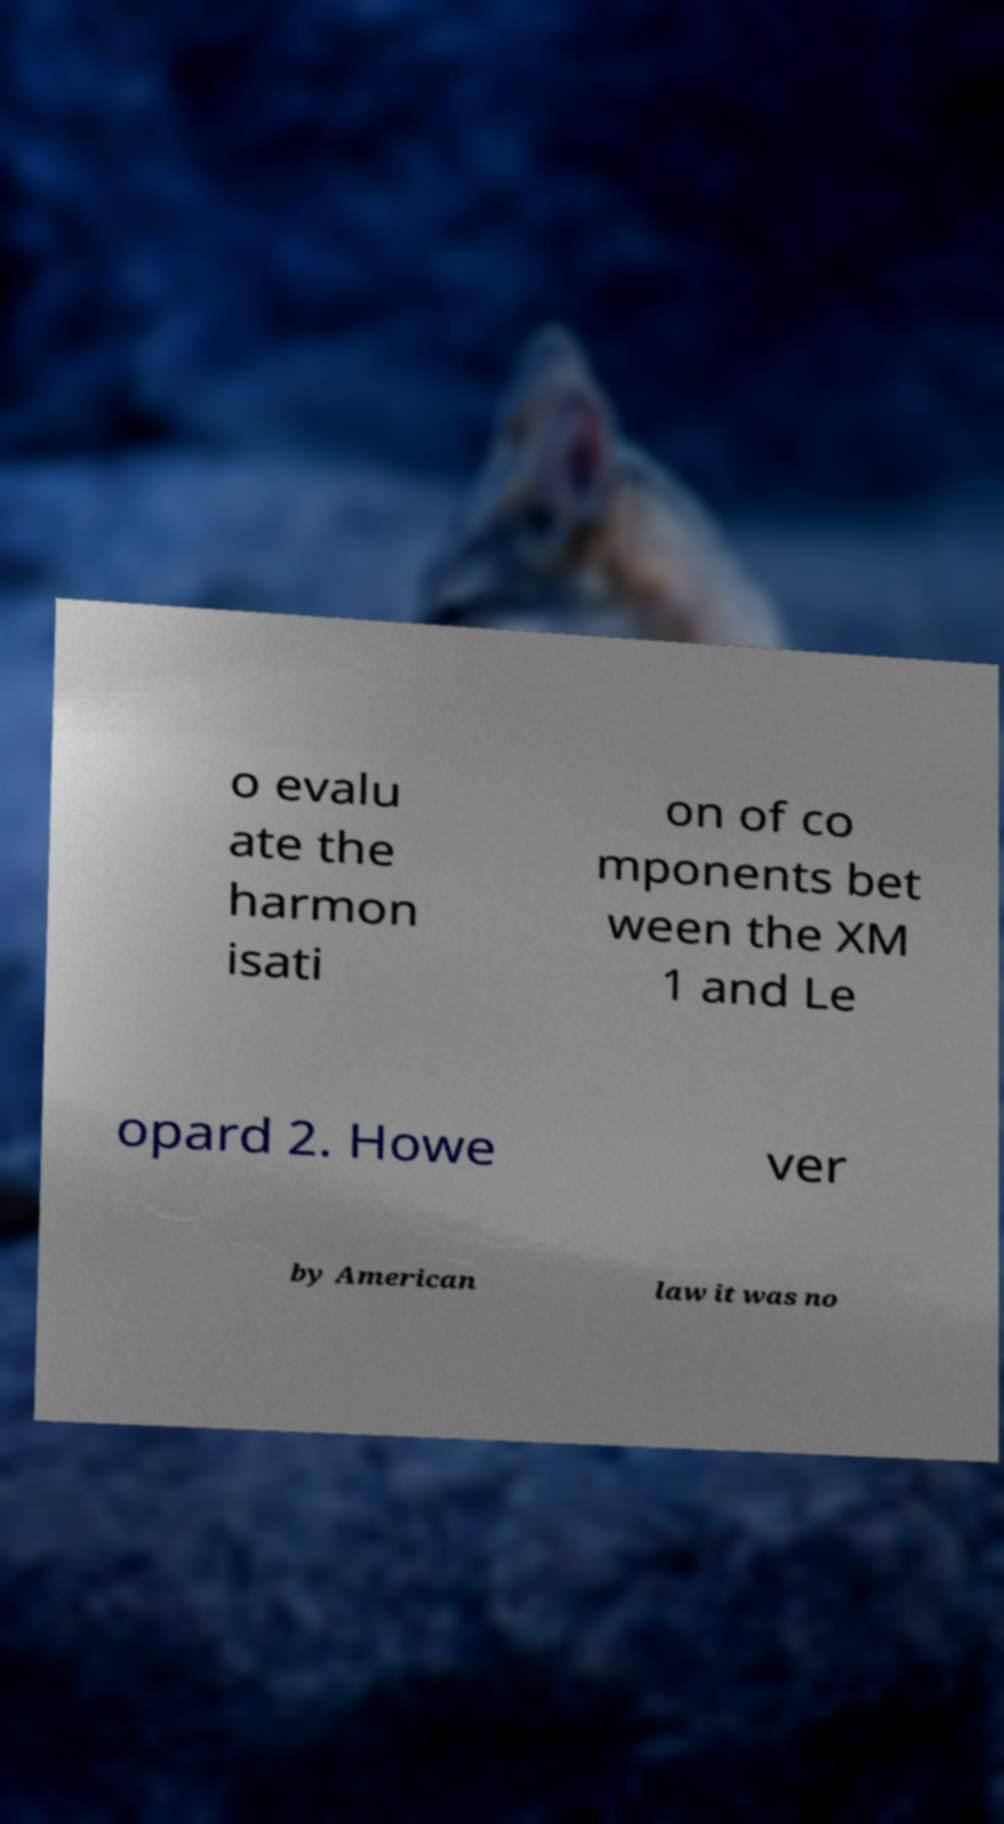Can you accurately transcribe the text from the provided image for me? o evalu ate the harmon isati on of co mponents bet ween the XM 1 and Le opard 2. Howe ver by American law it was no 